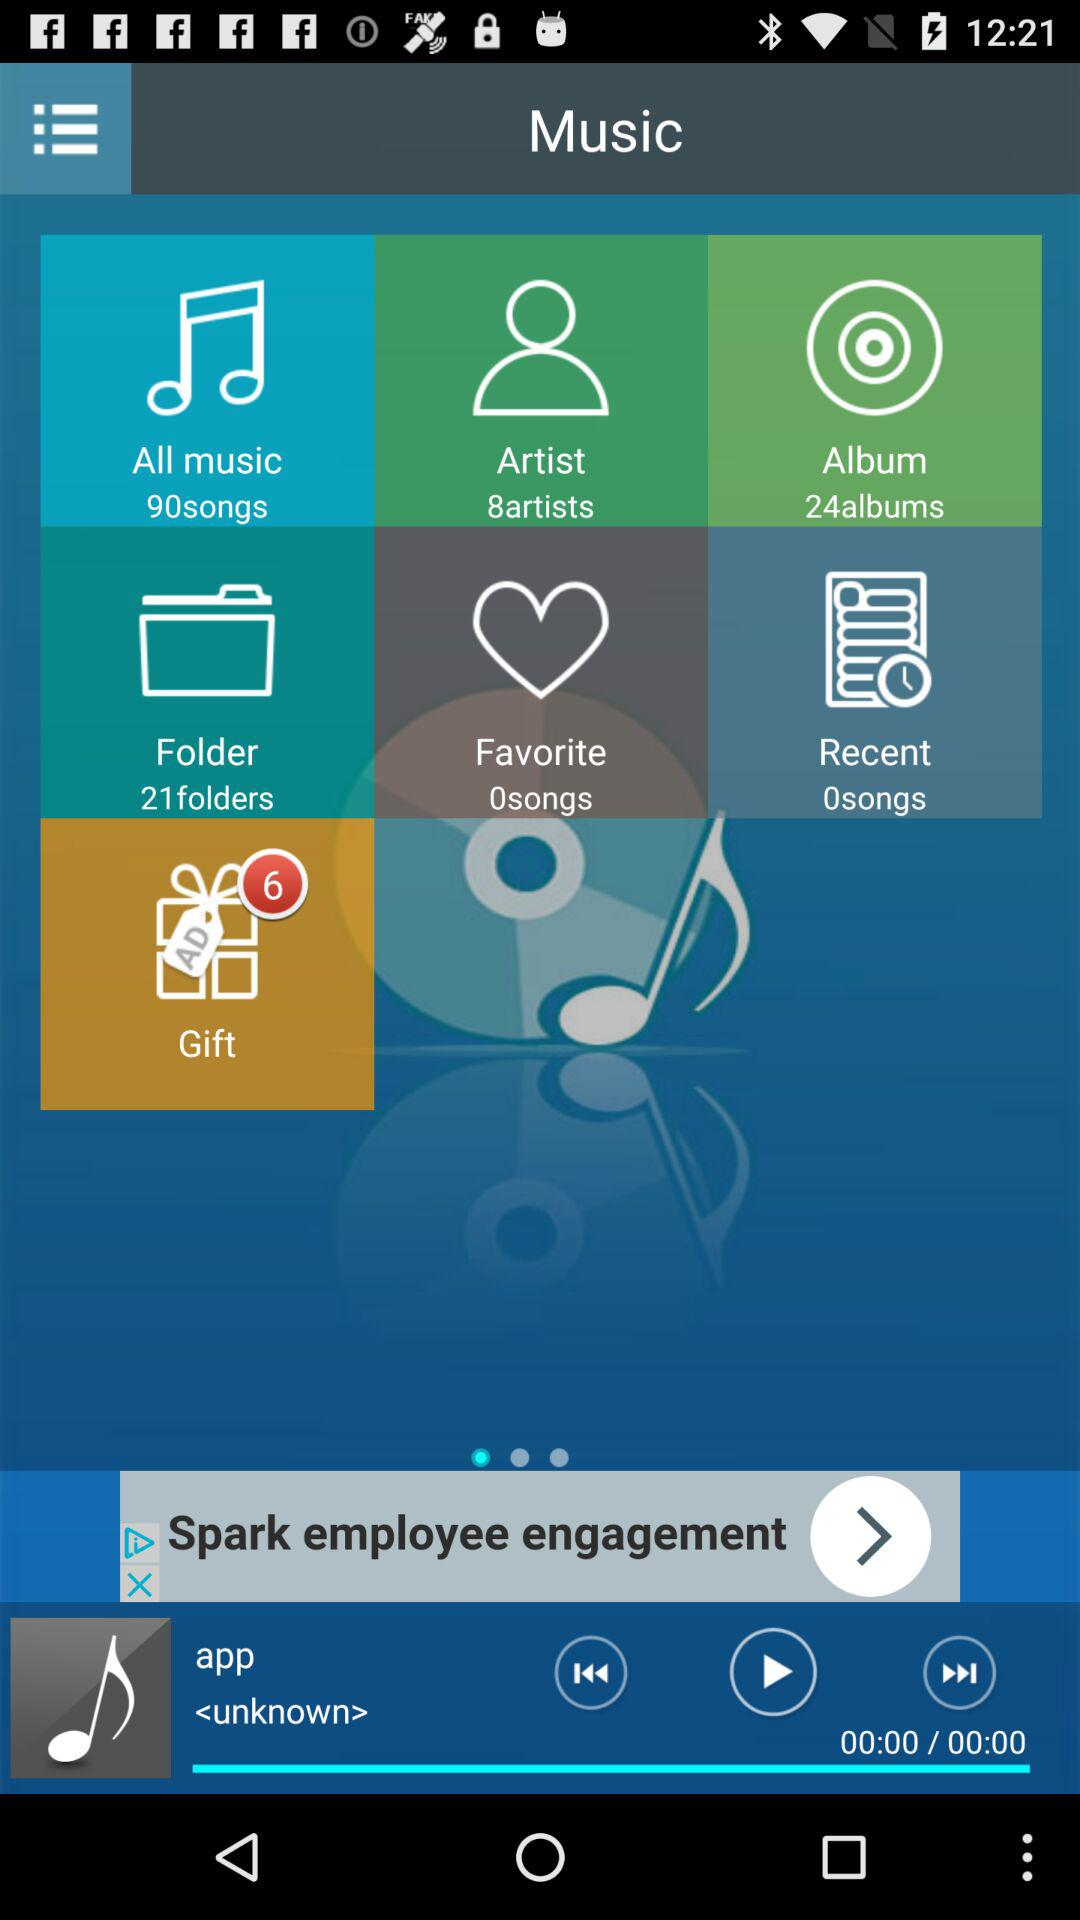How many more albums are there than artists?
Answer the question using a single word or phrase. 16 